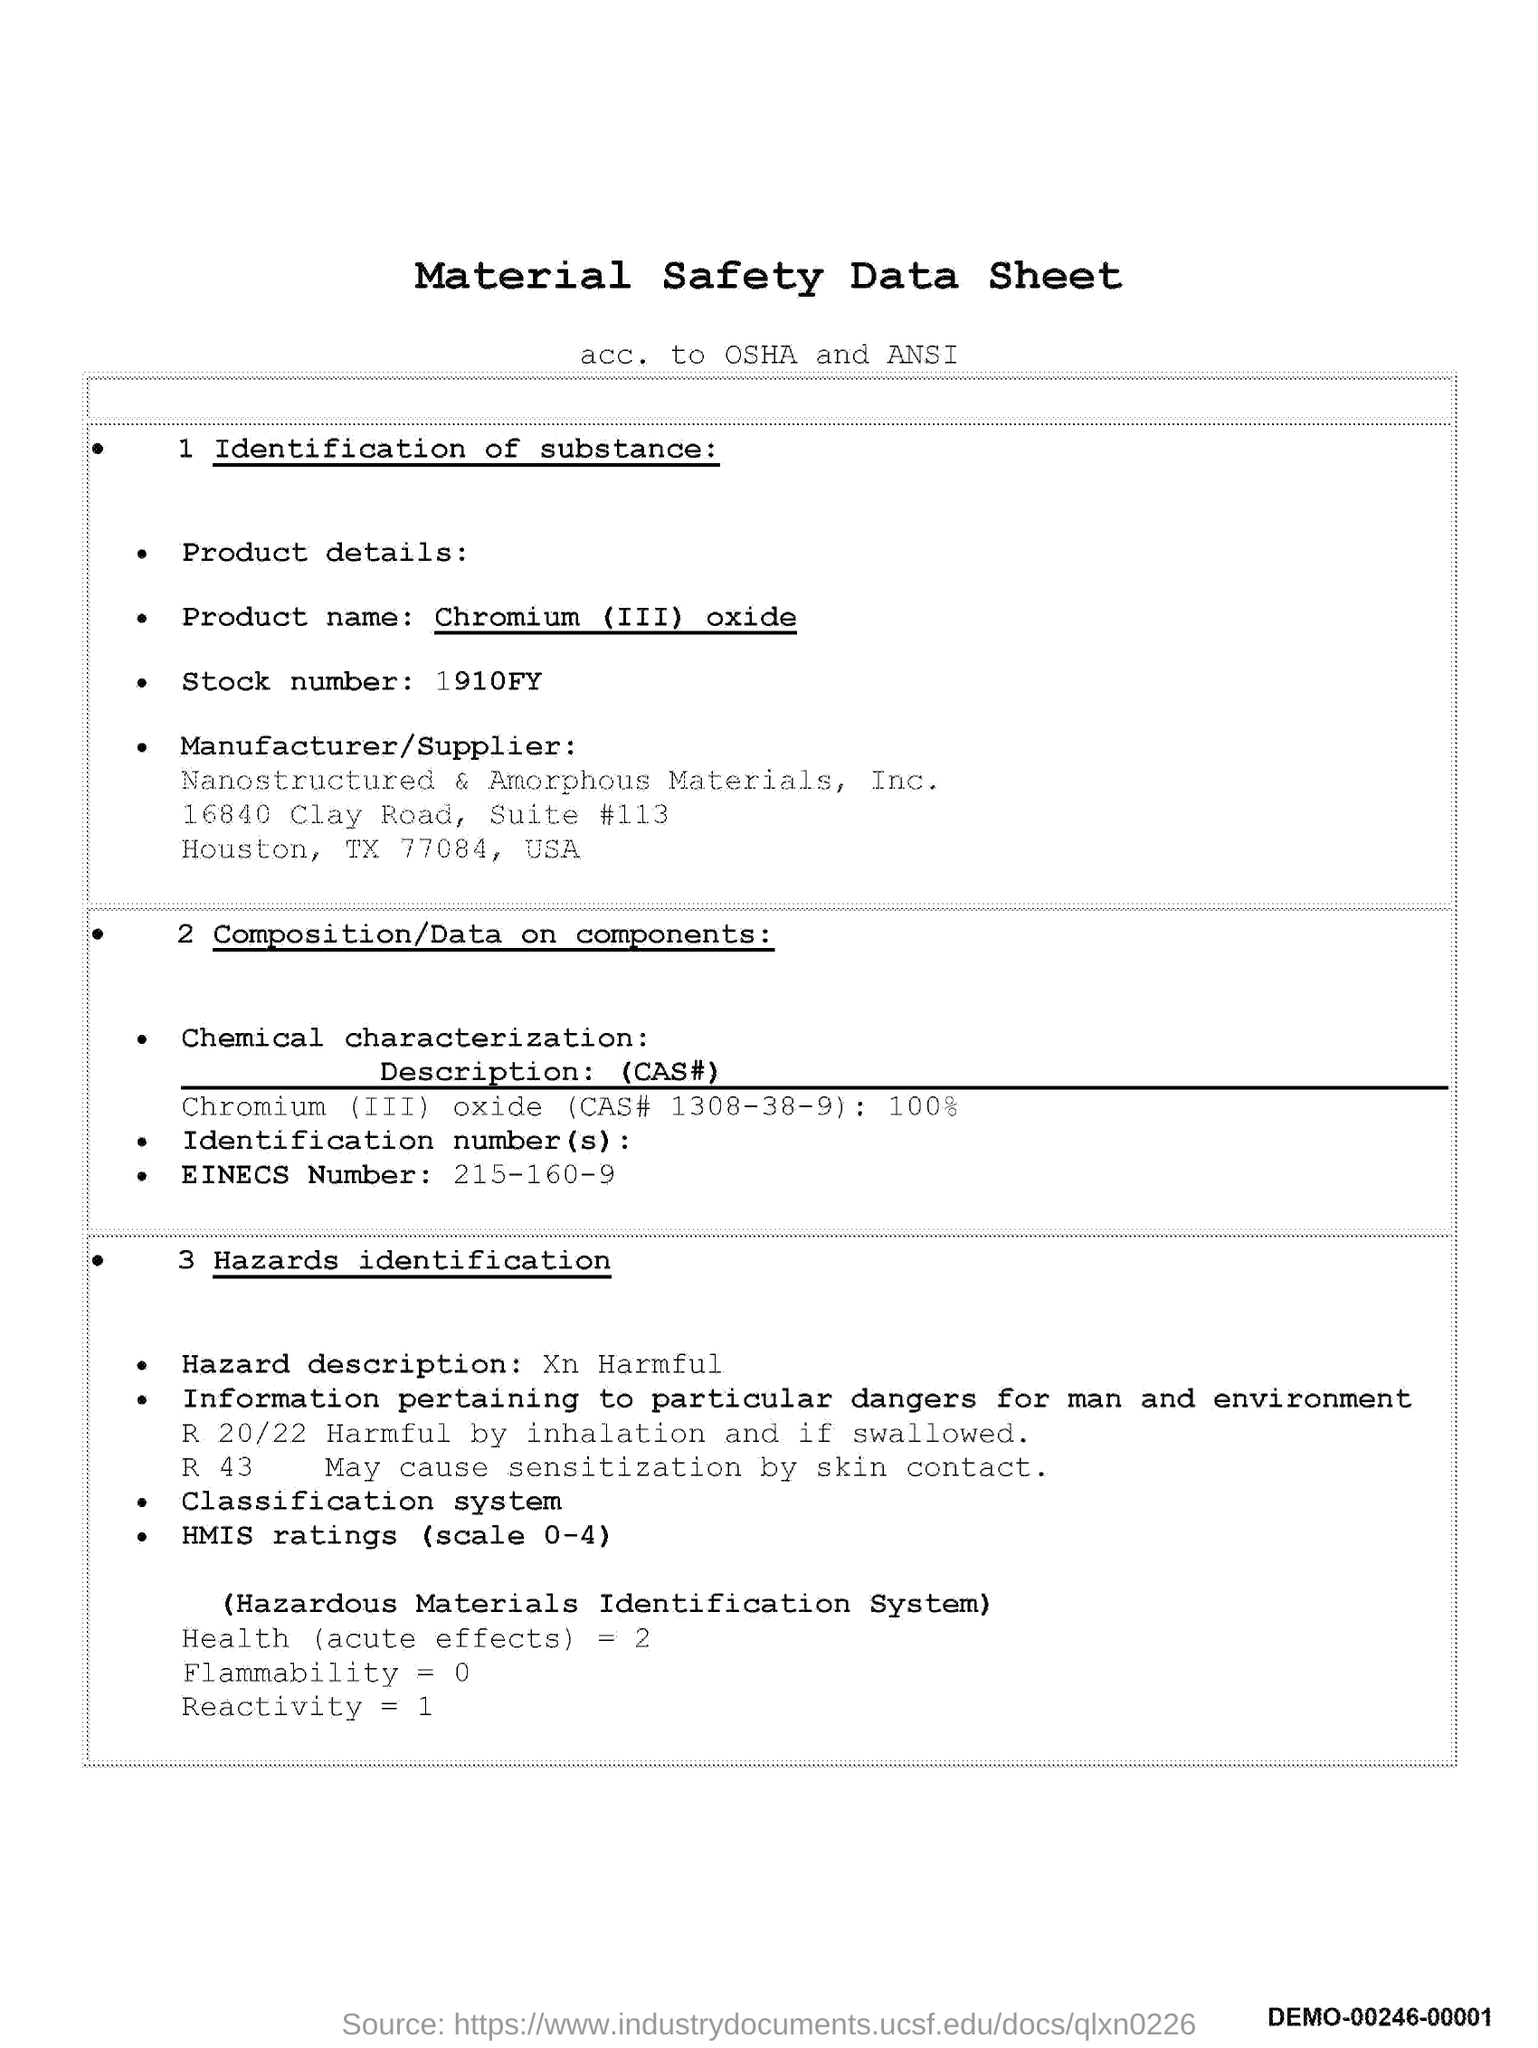What is the title of the document?
Give a very brief answer. Material safety data sheet. What is the stock number?
Provide a succinct answer. 1910FY. What is the EINECS number?
Offer a terse response. 215-160-9. 